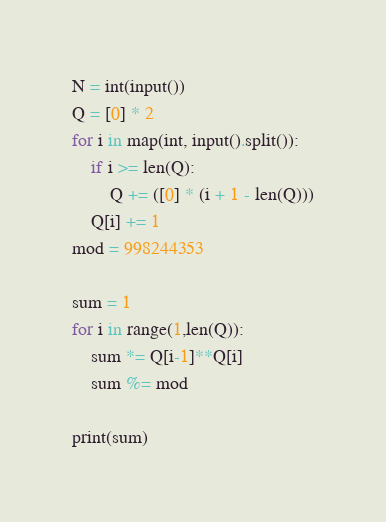<code> <loc_0><loc_0><loc_500><loc_500><_Python_>N = int(input())
Q = [0] * 2
for i in map(int, input().split()):
	if i >= len(Q):
		Q += ([0] * (i + 1 - len(Q)))
	Q[i] += 1
mod = 998244353

sum = 1
for i in range(1,len(Q)):
	sum *= Q[i-1]**Q[i]
	sum %= mod

print(sum)</code> 